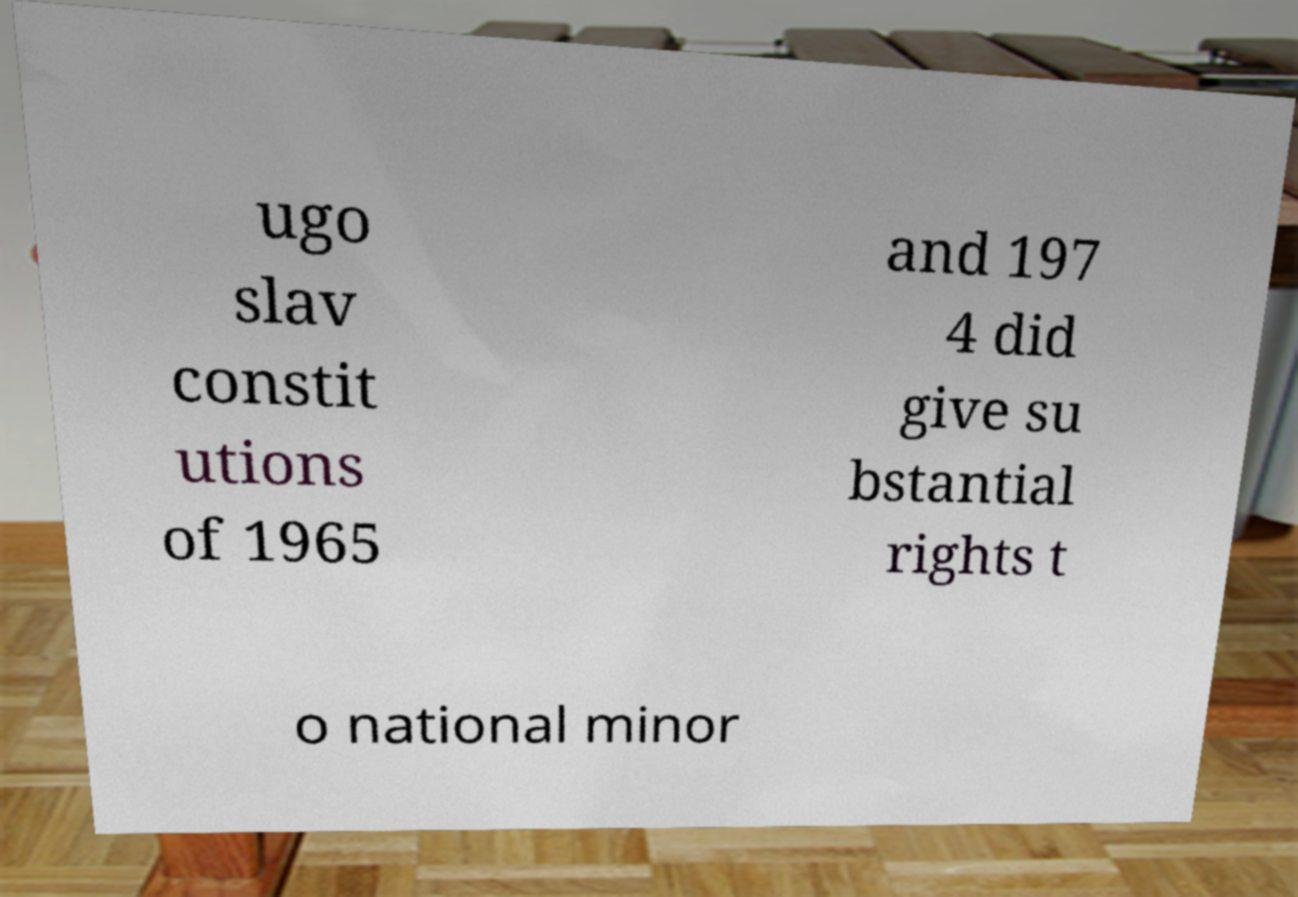Could you assist in decoding the text presented in this image and type it out clearly? ugo slav constit utions of 1965 and 197 4 did give su bstantial rights t o national minor 